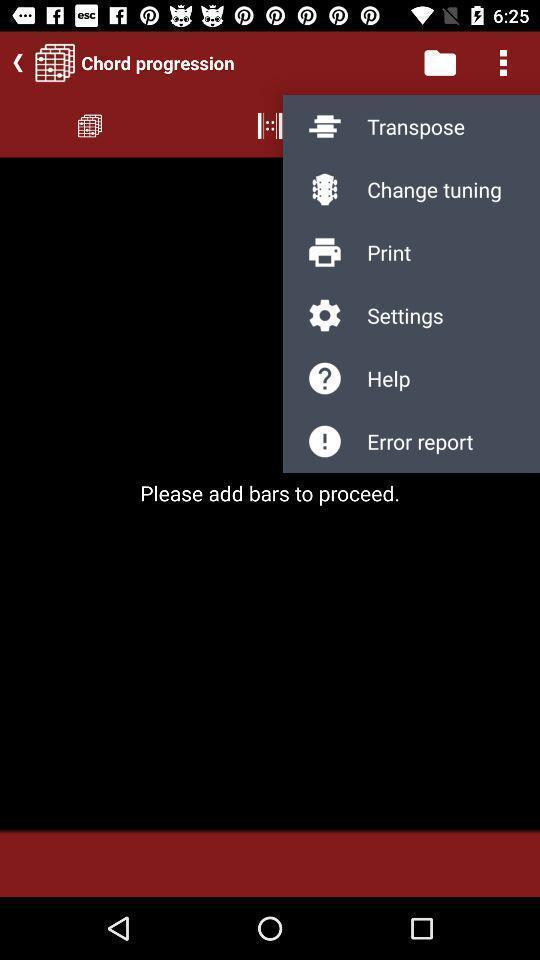Describe the content in this image. Screen displaying multiple options in a music learning application. 